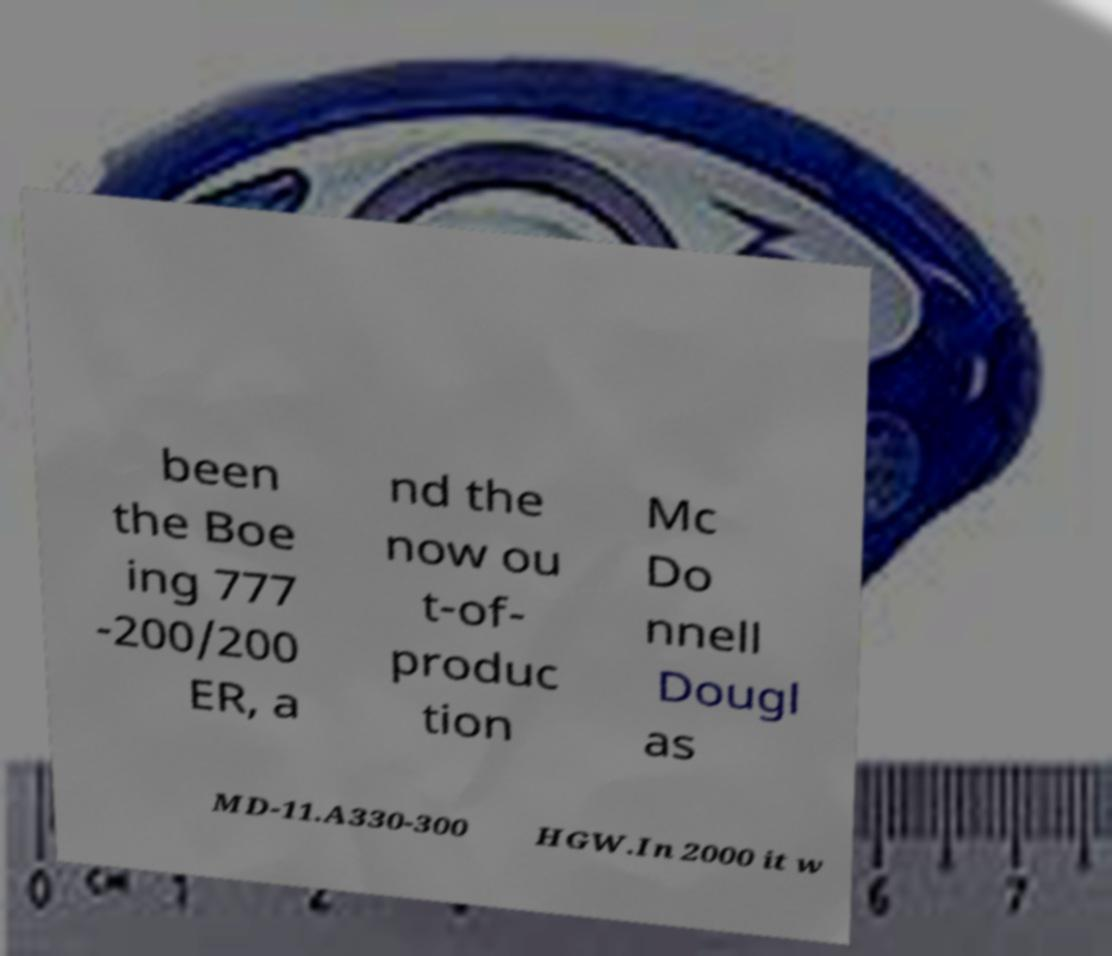Please identify and transcribe the text found in this image. been the Boe ing 777 -200/200 ER, a nd the now ou t-of- produc tion Mc Do nnell Dougl as MD-11.A330-300 HGW.In 2000 it w 